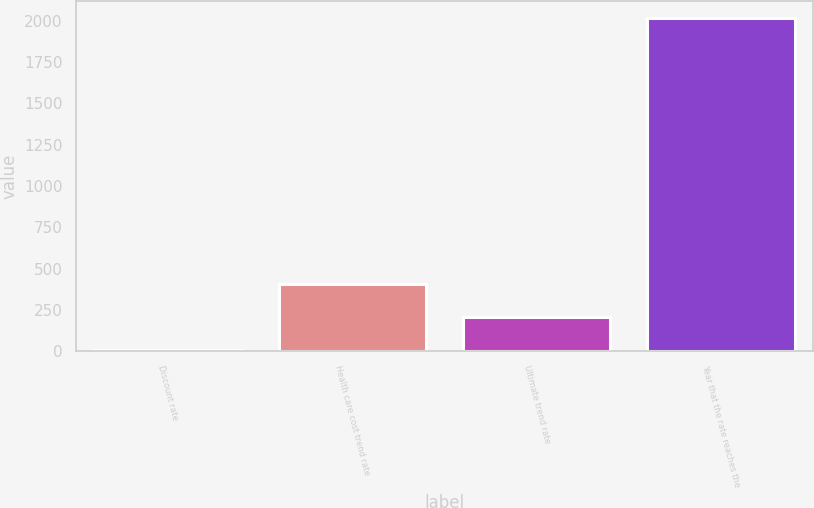<chart> <loc_0><loc_0><loc_500><loc_500><bar_chart><fcel>Discount rate<fcel>Health care cost trend rate<fcel>Ultimate trend rate<fcel>Year that the rate reaches the<nl><fcel>4.8<fcel>407.44<fcel>206.12<fcel>2018<nl></chart> 